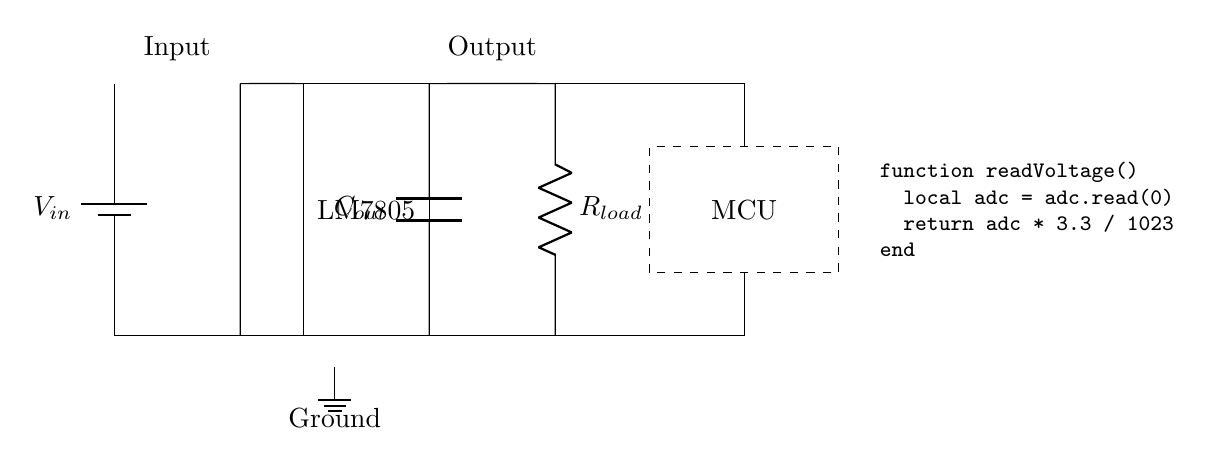What is the input voltage symbolized as? The input voltage is represented by the symbol \(V_{in}\) in the circuit. It is indicated near the battery component.
Answer: Vin Which component provides regulation in this circuit? The LM7805 chip is the component designated for voltage regulation as shown in the rectangle labeled LM7805. It converts the input voltage down to a regulated output.
Answer: LM7805 What does the output capacitor do in this circuit? The output capacitor, labeled \(C_{out}\), helps to smooth out the voltage output from the regulator by filtering any fluctuations or ripples. It is connected between the output and ground.
Answer: Smoothing What is the value of the output voltage? The output voltage is implied to be 5 volts, which is the standard output of the LM7805 voltage regulator as it steps down the input voltage to this value.
Answer: 5V How is the microcontroller powered in this diagram? The microcontroller is powered by the regulated output voltage which is connected to the load resistance \(R_{load}\). The connection lines show that the microcontroller receives voltage from the output of the LM7805.
Answer: Through output voltage What happens if the load resistance is increased? Increasing the load resistance \(R_{load}\) will decrease the current drawn from the circuit, potentially impacting the performance of the microcontroller especially if it requires a minimum current threshold.
Answer: Decreases current What is the purpose of the ground connection? The ground connection serves as a reference point for the circuit voltages, establishing a common return path for the electrical current to complete the circuit. It ensures proper operation of all components connected to the circuit.
Answer: Reference point 